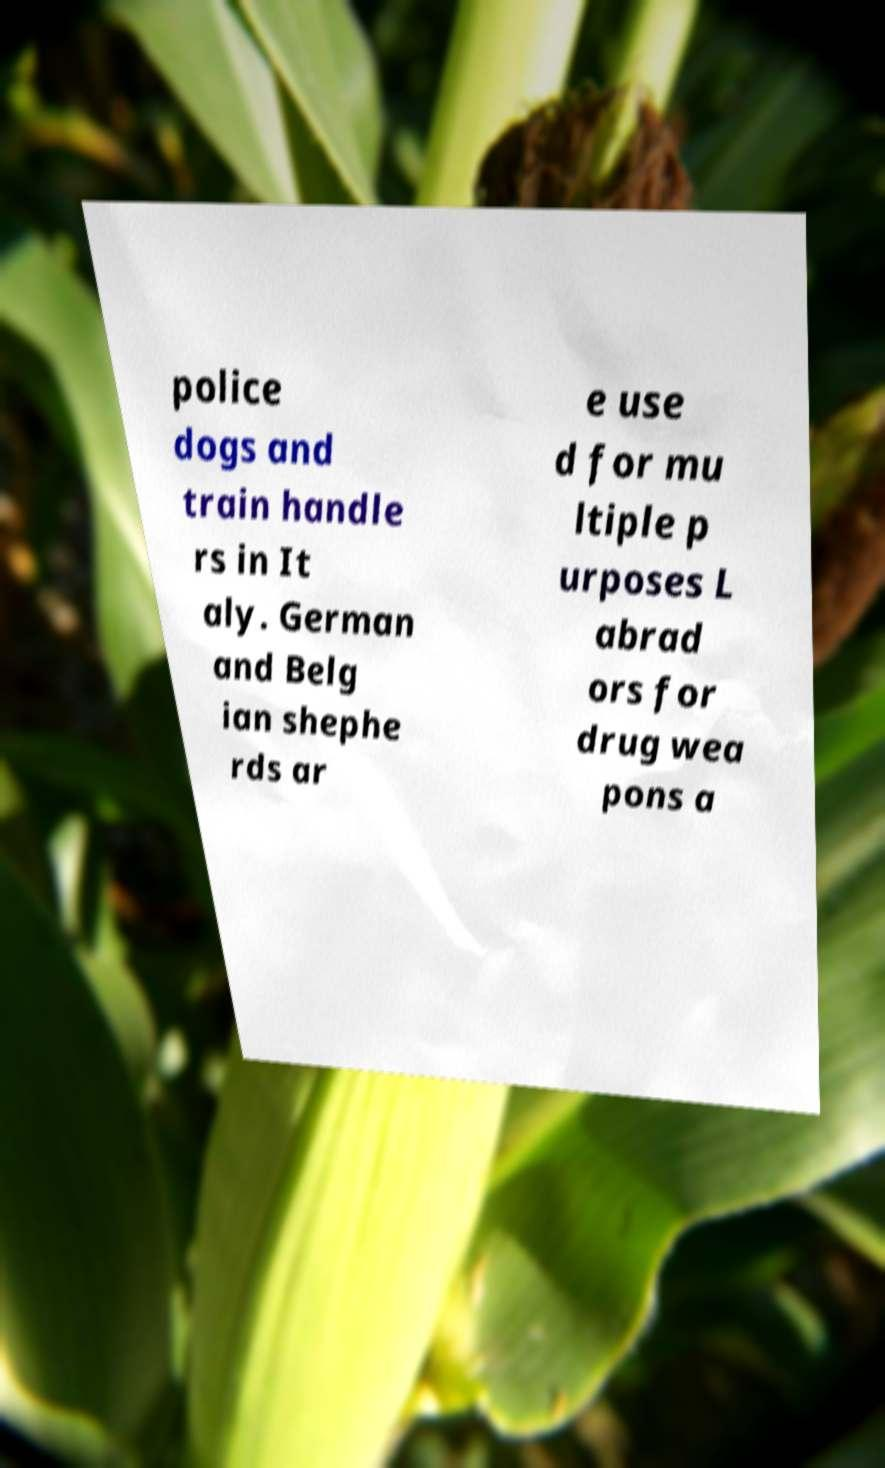For documentation purposes, I need the text within this image transcribed. Could you provide that? police dogs and train handle rs in It aly. German and Belg ian shephe rds ar e use d for mu ltiple p urposes L abrad ors for drug wea pons a 